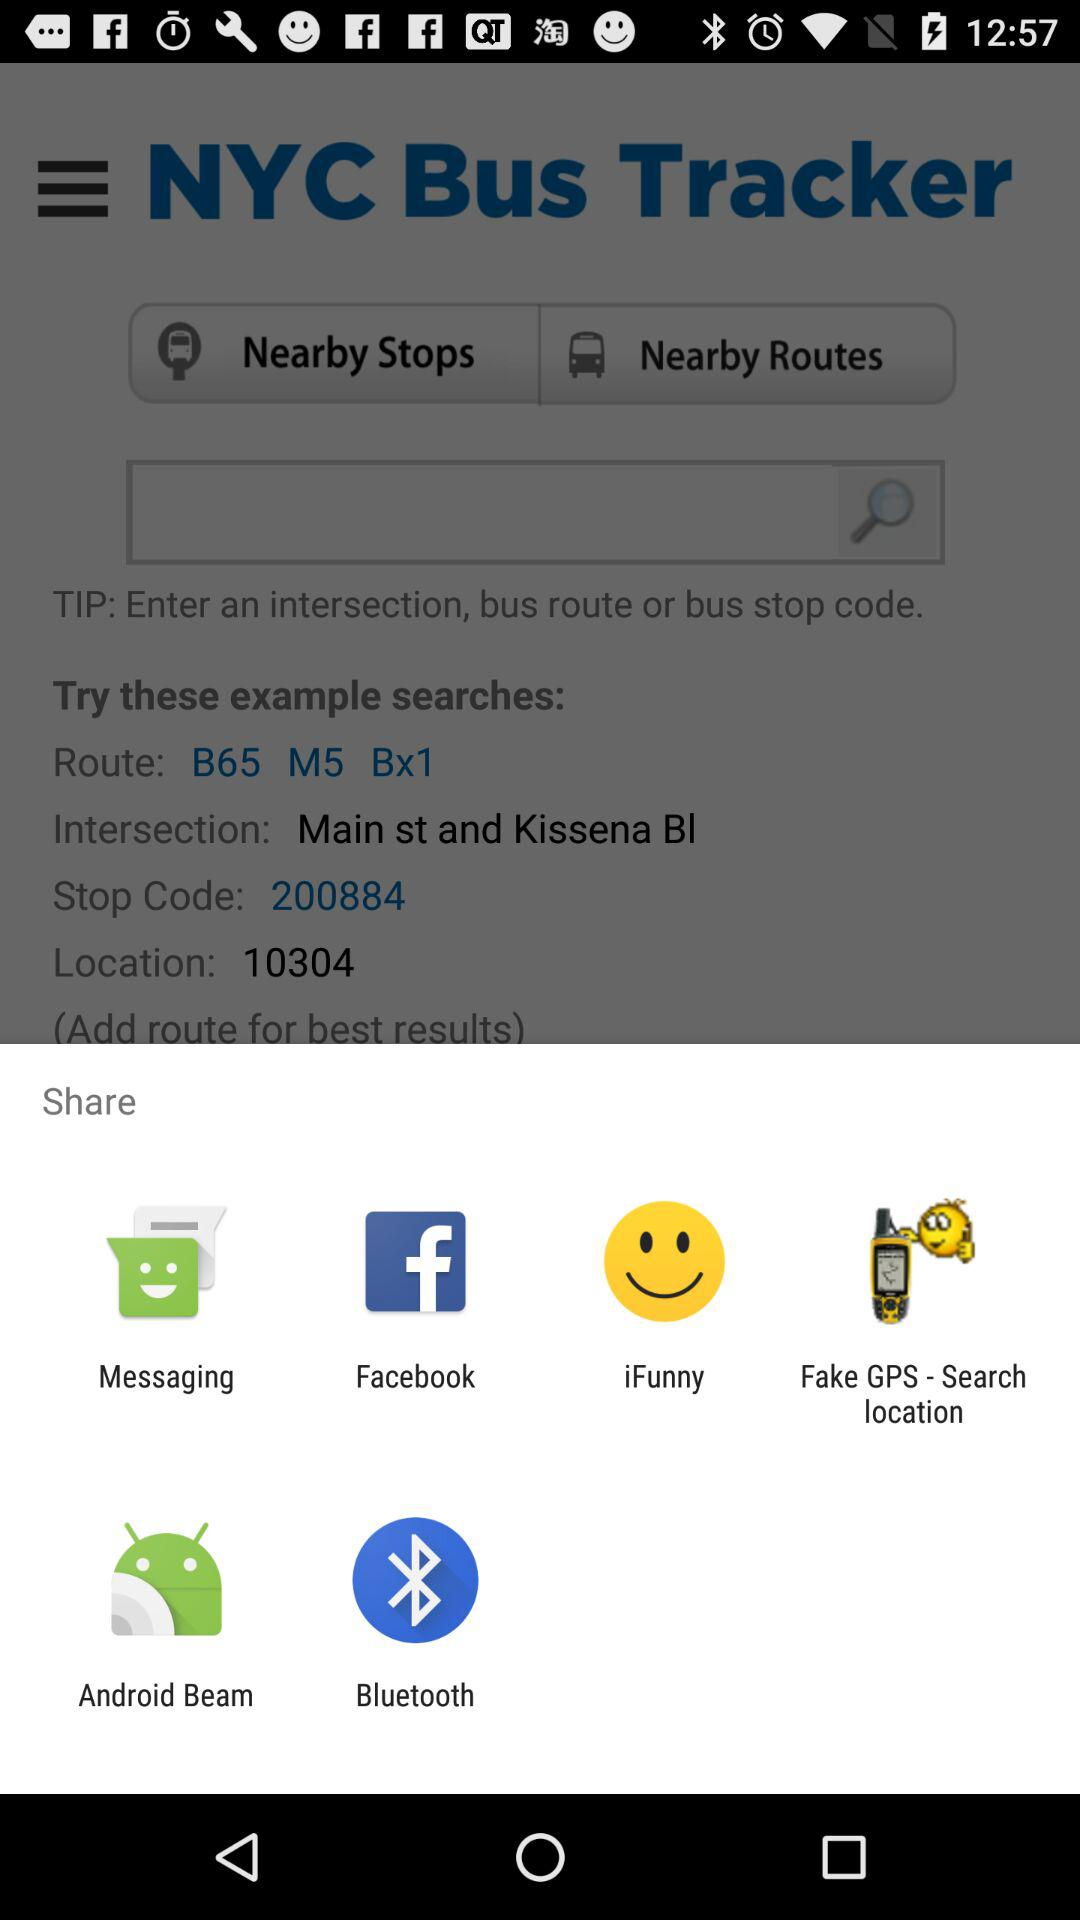What is the application name? The application name is "NYC Bus Tracker". 